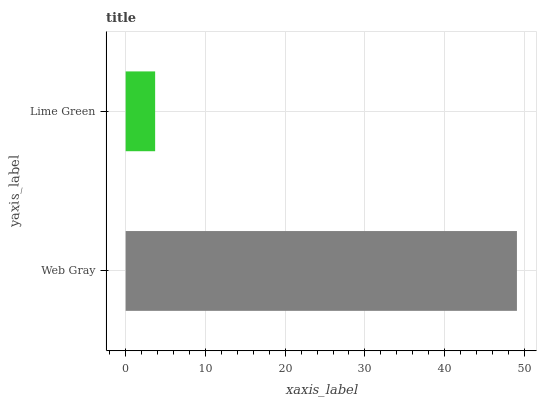Is Lime Green the minimum?
Answer yes or no. Yes. Is Web Gray the maximum?
Answer yes or no. Yes. Is Lime Green the maximum?
Answer yes or no. No. Is Web Gray greater than Lime Green?
Answer yes or no. Yes. Is Lime Green less than Web Gray?
Answer yes or no. Yes. Is Lime Green greater than Web Gray?
Answer yes or no. No. Is Web Gray less than Lime Green?
Answer yes or no. No. Is Web Gray the high median?
Answer yes or no. Yes. Is Lime Green the low median?
Answer yes or no. Yes. Is Lime Green the high median?
Answer yes or no. No. Is Web Gray the low median?
Answer yes or no. No. 